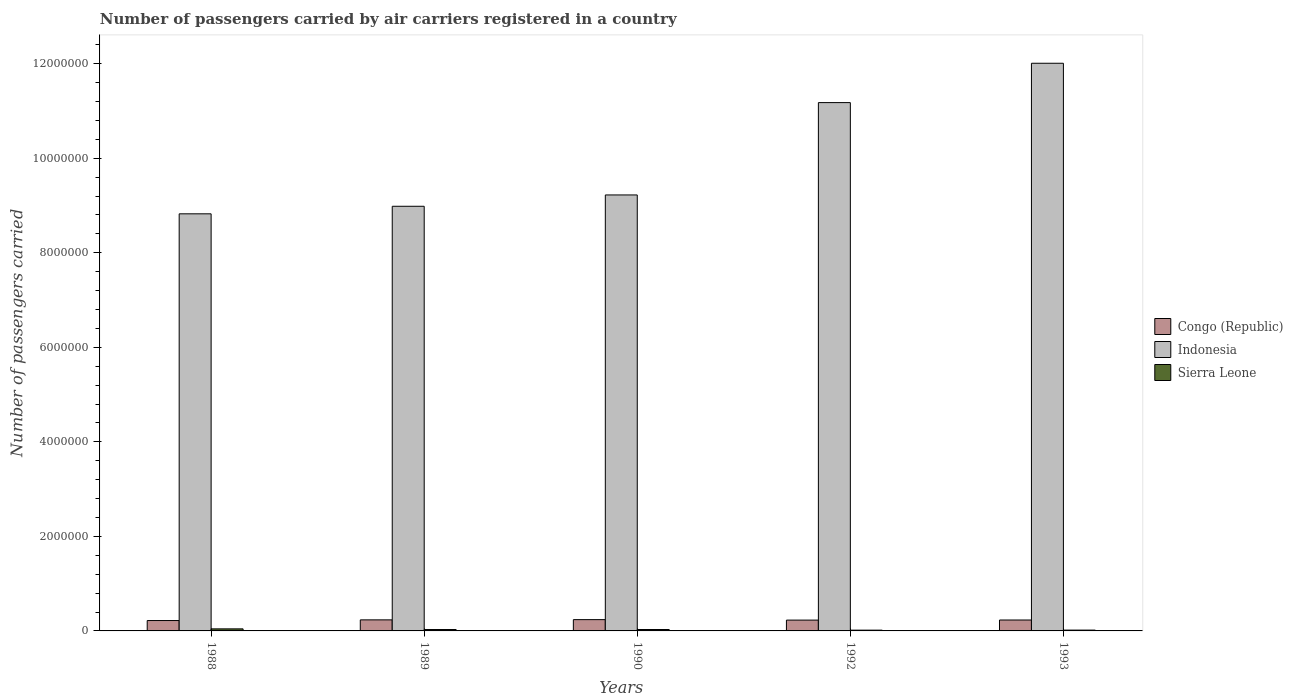How many different coloured bars are there?
Your answer should be compact. 3. How many groups of bars are there?
Offer a very short reply. 5. Are the number of bars per tick equal to the number of legend labels?
Provide a succinct answer. Yes. Are the number of bars on each tick of the X-axis equal?
Make the answer very short. Yes. How many bars are there on the 1st tick from the right?
Your response must be concise. 3. What is the label of the 2nd group of bars from the left?
Offer a terse response. 1989. In how many cases, is the number of bars for a given year not equal to the number of legend labels?
Your answer should be very brief. 0. What is the number of passengers carried by air carriers in Sierra Leone in 1993?
Your answer should be compact. 1.75e+04. Across all years, what is the maximum number of passengers carried by air carriers in Indonesia?
Keep it short and to the point. 1.20e+07. Across all years, what is the minimum number of passengers carried by air carriers in Indonesia?
Offer a terse response. 8.82e+06. In which year was the number of passengers carried by air carriers in Congo (Republic) maximum?
Provide a succinct answer. 1990. In which year was the number of passengers carried by air carriers in Indonesia minimum?
Ensure brevity in your answer.  1988. What is the total number of passengers carried by air carriers in Sierra Leone in the graph?
Keep it short and to the point. 1.37e+05. What is the difference between the number of passengers carried by air carriers in Indonesia in 1989 and that in 1990?
Keep it short and to the point. -2.40e+05. What is the difference between the number of passengers carried by air carriers in Indonesia in 1988 and the number of passengers carried by air carriers in Congo (Republic) in 1990?
Provide a short and direct response. 8.58e+06. What is the average number of passengers carried by air carriers in Indonesia per year?
Ensure brevity in your answer.  1.00e+07. In the year 1988, what is the difference between the number of passengers carried by air carriers in Congo (Republic) and number of passengers carried by air carriers in Sierra Leone?
Your answer should be very brief. 1.76e+05. In how many years, is the number of passengers carried by air carriers in Sierra Leone greater than 1200000?
Your response must be concise. 0. What is the ratio of the number of passengers carried by air carriers in Indonesia in 1989 to that in 1993?
Your answer should be very brief. 0.75. Is the number of passengers carried by air carriers in Congo (Republic) in 1989 less than that in 1993?
Your answer should be very brief. No. What is the difference between the highest and the second highest number of passengers carried by air carriers in Congo (Republic)?
Provide a short and direct response. 5100. What is the difference between the highest and the lowest number of passengers carried by air carriers in Sierra Leone?
Offer a very short reply. 2.71e+04. What does the 1st bar from the left in 1989 represents?
Your response must be concise. Congo (Republic). What does the 1st bar from the right in 1988 represents?
Give a very brief answer. Sierra Leone. How many bars are there?
Provide a succinct answer. 15. How many years are there in the graph?
Make the answer very short. 5. What is the difference between two consecutive major ticks on the Y-axis?
Ensure brevity in your answer.  2.00e+06. Does the graph contain any zero values?
Provide a succinct answer. No. How many legend labels are there?
Make the answer very short. 3. How are the legend labels stacked?
Offer a terse response. Vertical. What is the title of the graph?
Keep it short and to the point. Number of passengers carried by air carriers registered in a country. What is the label or title of the Y-axis?
Your response must be concise. Number of passengers carried. What is the Number of passengers carried of Congo (Republic) in 1988?
Your answer should be compact. 2.20e+05. What is the Number of passengers carried in Indonesia in 1988?
Offer a terse response. 8.82e+06. What is the Number of passengers carried in Sierra Leone in 1988?
Offer a terse response. 4.36e+04. What is the Number of passengers carried of Congo (Republic) in 1989?
Your answer should be very brief. 2.34e+05. What is the Number of passengers carried of Indonesia in 1989?
Your answer should be very brief. 8.98e+06. What is the Number of passengers carried in Sierra Leone in 1989?
Your response must be concise. 2.96e+04. What is the Number of passengers carried in Congo (Republic) in 1990?
Ensure brevity in your answer.  2.39e+05. What is the Number of passengers carried in Indonesia in 1990?
Offer a terse response. 9.22e+06. What is the Number of passengers carried in Sierra Leone in 1990?
Your response must be concise. 3.00e+04. What is the Number of passengers carried in Congo (Republic) in 1992?
Ensure brevity in your answer.  2.29e+05. What is the Number of passengers carried in Indonesia in 1992?
Your answer should be compact. 1.12e+07. What is the Number of passengers carried of Sierra Leone in 1992?
Keep it short and to the point. 1.65e+04. What is the Number of passengers carried of Congo (Republic) in 1993?
Provide a succinct answer. 2.31e+05. What is the Number of passengers carried of Indonesia in 1993?
Give a very brief answer. 1.20e+07. What is the Number of passengers carried of Sierra Leone in 1993?
Your answer should be compact. 1.75e+04. Across all years, what is the maximum Number of passengers carried in Congo (Republic)?
Offer a very short reply. 2.39e+05. Across all years, what is the maximum Number of passengers carried of Indonesia?
Offer a very short reply. 1.20e+07. Across all years, what is the maximum Number of passengers carried of Sierra Leone?
Offer a terse response. 4.36e+04. Across all years, what is the minimum Number of passengers carried in Congo (Republic)?
Your response must be concise. 2.20e+05. Across all years, what is the minimum Number of passengers carried in Indonesia?
Your response must be concise. 8.82e+06. Across all years, what is the minimum Number of passengers carried of Sierra Leone?
Your answer should be compact. 1.65e+04. What is the total Number of passengers carried in Congo (Republic) in the graph?
Offer a terse response. 1.15e+06. What is the total Number of passengers carried in Indonesia in the graph?
Provide a short and direct response. 5.02e+07. What is the total Number of passengers carried of Sierra Leone in the graph?
Make the answer very short. 1.37e+05. What is the difference between the Number of passengers carried in Congo (Republic) in 1988 and that in 1989?
Ensure brevity in your answer.  -1.41e+04. What is the difference between the Number of passengers carried in Indonesia in 1988 and that in 1989?
Provide a succinct answer. -1.60e+05. What is the difference between the Number of passengers carried in Sierra Leone in 1988 and that in 1989?
Provide a succinct answer. 1.40e+04. What is the difference between the Number of passengers carried of Congo (Republic) in 1988 and that in 1990?
Provide a succinct answer. -1.92e+04. What is the difference between the Number of passengers carried in Indonesia in 1988 and that in 1990?
Provide a short and direct response. -3.99e+05. What is the difference between the Number of passengers carried in Sierra Leone in 1988 and that in 1990?
Offer a terse response. 1.36e+04. What is the difference between the Number of passengers carried in Congo (Republic) in 1988 and that in 1992?
Provide a succinct answer. -9200. What is the difference between the Number of passengers carried of Indonesia in 1988 and that in 1992?
Provide a succinct answer. -2.35e+06. What is the difference between the Number of passengers carried of Sierra Leone in 1988 and that in 1992?
Ensure brevity in your answer.  2.71e+04. What is the difference between the Number of passengers carried of Congo (Republic) in 1988 and that in 1993?
Provide a short and direct response. -1.11e+04. What is the difference between the Number of passengers carried of Indonesia in 1988 and that in 1993?
Your answer should be very brief. -3.19e+06. What is the difference between the Number of passengers carried in Sierra Leone in 1988 and that in 1993?
Your response must be concise. 2.61e+04. What is the difference between the Number of passengers carried in Congo (Republic) in 1989 and that in 1990?
Your response must be concise. -5100. What is the difference between the Number of passengers carried of Indonesia in 1989 and that in 1990?
Provide a succinct answer. -2.40e+05. What is the difference between the Number of passengers carried of Sierra Leone in 1989 and that in 1990?
Ensure brevity in your answer.  -400. What is the difference between the Number of passengers carried in Congo (Republic) in 1989 and that in 1992?
Provide a succinct answer. 4900. What is the difference between the Number of passengers carried in Indonesia in 1989 and that in 1992?
Provide a succinct answer. -2.19e+06. What is the difference between the Number of passengers carried of Sierra Leone in 1989 and that in 1992?
Ensure brevity in your answer.  1.31e+04. What is the difference between the Number of passengers carried in Congo (Republic) in 1989 and that in 1993?
Keep it short and to the point. 3000. What is the difference between the Number of passengers carried of Indonesia in 1989 and that in 1993?
Offer a very short reply. -3.03e+06. What is the difference between the Number of passengers carried in Sierra Leone in 1989 and that in 1993?
Offer a very short reply. 1.21e+04. What is the difference between the Number of passengers carried of Congo (Republic) in 1990 and that in 1992?
Your response must be concise. 10000. What is the difference between the Number of passengers carried in Indonesia in 1990 and that in 1992?
Keep it short and to the point. -1.95e+06. What is the difference between the Number of passengers carried in Sierra Leone in 1990 and that in 1992?
Offer a very short reply. 1.35e+04. What is the difference between the Number of passengers carried of Congo (Republic) in 1990 and that in 1993?
Your answer should be compact. 8100. What is the difference between the Number of passengers carried of Indonesia in 1990 and that in 1993?
Your response must be concise. -2.79e+06. What is the difference between the Number of passengers carried of Sierra Leone in 1990 and that in 1993?
Give a very brief answer. 1.25e+04. What is the difference between the Number of passengers carried in Congo (Republic) in 1992 and that in 1993?
Provide a succinct answer. -1900. What is the difference between the Number of passengers carried of Indonesia in 1992 and that in 1993?
Your response must be concise. -8.32e+05. What is the difference between the Number of passengers carried in Sierra Leone in 1992 and that in 1993?
Offer a terse response. -1000. What is the difference between the Number of passengers carried of Congo (Republic) in 1988 and the Number of passengers carried of Indonesia in 1989?
Your answer should be very brief. -8.76e+06. What is the difference between the Number of passengers carried of Congo (Republic) in 1988 and the Number of passengers carried of Sierra Leone in 1989?
Provide a succinct answer. 1.90e+05. What is the difference between the Number of passengers carried in Indonesia in 1988 and the Number of passengers carried in Sierra Leone in 1989?
Your answer should be compact. 8.79e+06. What is the difference between the Number of passengers carried in Congo (Republic) in 1988 and the Number of passengers carried in Indonesia in 1990?
Offer a terse response. -9.00e+06. What is the difference between the Number of passengers carried of Congo (Republic) in 1988 and the Number of passengers carried of Sierra Leone in 1990?
Keep it short and to the point. 1.90e+05. What is the difference between the Number of passengers carried in Indonesia in 1988 and the Number of passengers carried in Sierra Leone in 1990?
Make the answer very short. 8.79e+06. What is the difference between the Number of passengers carried in Congo (Republic) in 1988 and the Number of passengers carried in Indonesia in 1992?
Give a very brief answer. -1.10e+07. What is the difference between the Number of passengers carried in Congo (Republic) in 1988 and the Number of passengers carried in Sierra Leone in 1992?
Ensure brevity in your answer.  2.03e+05. What is the difference between the Number of passengers carried in Indonesia in 1988 and the Number of passengers carried in Sierra Leone in 1992?
Make the answer very short. 8.81e+06. What is the difference between the Number of passengers carried in Congo (Republic) in 1988 and the Number of passengers carried in Indonesia in 1993?
Give a very brief answer. -1.18e+07. What is the difference between the Number of passengers carried in Congo (Republic) in 1988 and the Number of passengers carried in Sierra Leone in 1993?
Offer a very short reply. 2.02e+05. What is the difference between the Number of passengers carried of Indonesia in 1988 and the Number of passengers carried of Sierra Leone in 1993?
Your response must be concise. 8.81e+06. What is the difference between the Number of passengers carried in Congo (Republic) in 1989 and the Number of passengers carried in Indonesia in 1990?
Provide a short and direct response. -8.99e+06. What is the difference between the Number of passengers carried of Congo (Republic) in 1989 and the Number of passengers carried of Sierra Leone in 1990?
Offer a terse response. 2.04e+05. What is the difference between the Number of passengers carried in Indonesia in 1989 and the Number of passengers carried in Sierra Leone in 1990?
Provide a succinct answer. 8.95e+06. What is the difference between the Number of passengers carried in Congo (Republic) in 1989 and the Number of passengers carried in Indonesia in 1992?
Ensure brevity in your answer.  -1.09e+07. What is the difference between the Number of passengers carried of Congo (Republic) in 1989 and the Number of passengers carried of Sierra Leone in 1992?
Your response must be concise. 2.17e+05. What is the difference between the Number of passengers carried in Indonesia in 1989 and the Number of passengers carried in Sierra Leone in 1992?
Give a very brief answer. 8.97e+06. What is the difference between the Number of passengers carried of Congo (Republic) in 1989 and the Number of passengers carried of Indonesia in 1993?
Give a very brief answer. -1.18e+07. What is the difference between the Number of passengers carried of Congo (Republic) in 1989 and the Number of passengers carried of Sierra Leone in 1993?
Your answer should be very brief. 2.16e+05. What is the difference between the Number of passengers carried of Indonesia in 1989 and the Number of passengers carried of Sierra Leone in 1993?
Give a very brief answer. 8.97e+06. What is the difference between the Number of passengers carried in Congo (Republic) in 1990 and the Number of passengers carried in Indonesia in 1992?
Your response must be concise. -1.09e+07. What is the difference between the Number of passengers carried of Congo (Republic) in 1990 and the Number of passengers carried of Sierra Leone in 1992?
Ensure brevity in your answer.  2.22e+05. What is the difference between the Number of passengers carried of Indonesia in 1990 and the Number of passengers carried of Sierra Leone in 1992?
Give a very brief answer. 9.21e+06. What is the difference between the Number of passengers carried in Congo (Republic) in 1990 and the Number of passengers carried in Indonesia in 1993?
Your answer should be compact. -1.18e+07. What is the difference between the Number of passengers carried of Congo (Republic) in 1990 and the Number of passengers carried of Sierra Leone in 1993?
Your response must be concise. 2.21e+05. What is the difference between the Number of passengers carried of Indonesia in 1990 and the Number of passengers carried of Sierra Leone in 1993?
Give a very brief answer. 9.21e+06. What is the difference between the Number of passengers carried of Congo (Republic) in 1992 and the Number of passengers carried of Indonesia in 1993?
Offer a terse response. -1.18e+07. What is the difference between the Number of passengers carried in Congo (Republic) in 1992 and the Number of passengers carried in Sierra Leone in 1993?
Offer a terse response. 2.11e+05. What is the difference between the Number of passengers carried of Indonesia in 1992 and the Number of passengers carried of Sierra Leone in 1993?
Offer a very short reply. 1.12e+07. What is the average Number of passengers carried of Congo (Republic) per year?
Offer a terse response. 2.30e+05. What is the average Number of passengers carried in Indonesia per year?
Your response must be concise. 1.00e+07. What is the average Number of passengers carried in Sierra Leone per year?
Provide a succinct answer. 2.74e+04. In the year 1988, what is the difference between the Number of passengers carried of Congo (Republic) and Number of passengers carried of Indonesia?
Provide a short and direct response. -8.60e+06. In the year 1988, what is the difference between the Number of passengers carried in Congo (Republic) and Number of passengers carried in Sierra Leone?
Make the answer very short. 1.76e+05. In the year 1988, what is the difference between the Number of passengers carried in Indonesia and Number of passengers carried in Sierra Leone?
Provide a short and direct response. 8.78e+06. In the year 1989, what is the difference between the Number of passengers carried in Congo (Republic) and Number of passengers carried in Indonesia?
Your answer should be compact. -8.75e+06. In the year 1989, what is the difference between the Number of passengers carried of Congo (Republic) and Number of passengers carried of Sierra Leone?
Your response must be concise. 2.04e+05. In the year 1989, what is the difference between the Number of passengers carried in Indonesia and Number of passengers carried in Sierra Leone?
Your response must be concise. 8.95e+06. In the year 1990, what is the difference between the Number of passengers carried of Congo (Republic) and Number of passengers carried of Indonesia?
Offer a very short reply. -8.98e+06. In the year 1990, what is the difference between the Number of passengers carried in Congo (Republic) and Number of passengers carried in Sierra Leone?
Make the answer very short. 2.09e+05. In the year 1990, what is the difference between the Number of passengers carried of Indonesia and Number of passengers carried of Sierra Leone?
Your answer should be compact. 9.19e+06. In the year 1992, what is the difference between the Number of passengers carried in Congo (Republic) and Number of passengers carried in Indonesia?
Your answer should be very brief. -1.09e+07. In the year 1992, what is the difference between the Number of passengers carried of Congo (Republic) and Number of passengers carried of Sierra Leone?
Ensure brevity in your answer.  2.12e+05. In the year 1992, what is the difference between the Number of passengers carried in Indonesia and Number of passengers carried in Sierra Leone?
Keep it short and to the point. 1.12e+07. In the year 1993, what is the difference between the Number of passengers carried in Congo (Republic) and Number of passengers carried in Indonesia?
Make the answer very short. -1.18e+07. In the year 1993, what is the difference between the Number of passengers carried of Congo (Republic) and Number of passengers carried of Sierra Leone?
Offer a very short reply. 2.13e+05. In the year 1993, what is the difference between the Number of passengers carried of Indonesia and Number of passengers carried of Sierra Leone?
Provide a short and direct response. 1.20e+07. What is the ratio of the Number of passengers carried of Congo (Republic) in 1988 to that in 1989?
Provide a short and direct response. 0.94. What is the ratio of the Number of passengers carried in Indonesia in 1988 to that in 1989?
Ensure brevity in your answer.  0.98. What is the ratio of the Number of passengers carried in Sierra Leone in 1988 to that in 1989?
Provide a short and direct response. 1.47. What is the ratio of the Number of passengers carried of Congo (Republic) in 1988 to that in 1990?
Your answer should be compact. 0.92. What is the ratio of the Number of passengers carried of Indonesia in 1988 to that in 1990?
Offer a very short reply. 0.96. What is the ratio of the Number of passengers carried of Sierra Leone in 1988 to that in 1990?
Keep it short and to the point. 1.45. What is the ratio of the Number of passengers carried in Congo (Republic) in 1988 to that in 1992?
Provide a short and direct response. 0.96. What is the ratio of the Number of passengers carried in Indonesia in 1988 to that in 1992?
Offer a very short reply. 0.79. What is the ratio of the Number of passengers carried in Sierra Leone in 1988 to that in 1992?
Ensure brevity in your answer.  2.64. What is the ratio of the Number of passengers carried in Congo (Republic) in 1988 to that in 1993?
Keep it short and to the point. 0.95. What is the ratio of the Number of passengers carried of Indonesia in 1988 to that in 1993?
Ensure brevity in your answer.  0.73. What is the ratio of the Number of passengers carried in Sierra Leone in 1988 to that in 1993?
Your answer should be compact. 2.49. What is the ratio of the Number of passengers carried in Congo (Republic) in 1989 to that in 1990?
Your response must be concise. 0.98. What is the ratio of the Number of passengers carried of Sierra Leone in 1989 to that in 1990?
Offer a terse response. 0.99. What is the ratio of the Number of passengers carried of Congo (Republic) in 1989 to that in 1992?
Your response must be concise. 1.02. What is the ratio of the Number of passengers carried of Indonesia in 1989 to that in 1992?
Provide a short and direct response. 0.8. What is the ratio of the Number of passengers carried of Sierra Leone in 1989 to that in 1992?
Provide a short and direct response. 1.79. What is the ratio of the Number of passengers carried of Indonesia in 1989 to that in 1993?
Your response must be concise. 0.75. What is the ratio of the Number of passengers carried in Sierra Leone in 1989 to that in 1993?
Your answer should be compact. 1.69. What is the ratio of the Number of passengers carried in Congo (Republic) in 1990 to that in 1992?
Make the answer very short. 1.04. What is the ratio of the Number of passengers carried of Indonesia in 1990 to that in 1992?
Your answer should be very brief. 0.83. What is the ratio of the Number of passengers carried of Sierra Leone in 1990 to that in 1992?
Provide a short and direct response. 1.82. What is the ratio of the Number of passengers carried in Congo (Republic) in 1990 to that in 1993?
Ensure brevity in your answer.  1.04. What is the ratio of the Number of passengers carried of Indonesia in 1990 to that in 1993?
Offer a very short reply. 0.77. What is the ratio of the Number of passengers carried of Sierra Leone in 1990 to that in 1993?
Make the answer very short. 1.71. What is the ratio of the Number of passengers carried of Congo (Republic) in 1992 to that in 1993?
Offer a terse response. 0.99. What is the ratio of the Number of passengers carried in Indonesia in 1992 to that in 1993?
Offer a very short reply. 0.93. What is the ratio of the Number of passengers carried in Sierra Leone in 1992 to that in 1993?
Make the answer very short. 0.94. What is the difference between the highest and the second highest Number of passengers carried of Congo (Republic)?
Offer a very short reply. 5100. What is the difference between the highest and the second highest Number of passengers carried in Indonesia?
Your answer should be very brief. 8.32e+05. What is the difference between the highest and the second highest Number of passengers carried of Sierra Leone?
Your response must be concise. 1.36e+04. What is the difference between the highest and the lowest Number of passengers carried of Congo (Republic)?
Offer a terse response. 1.92e+04. What is the difference between the highest and the lowest Number of passengers carried of Indonesia?
Give a very brief answer. 3.19e+06. What is the difference between the highest and the lowest Number of passengers carried of Sierra Leone?
Give a very brief answer. 2.71e+04. 